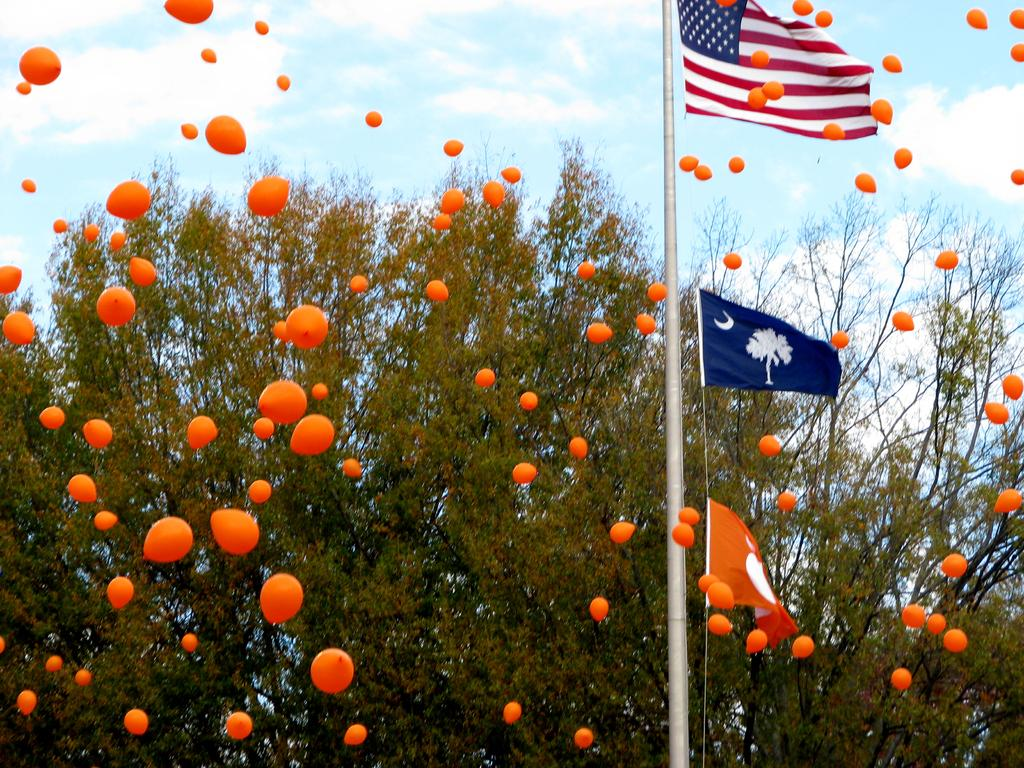What is the main structure in the image? There is a pole in the image. What is attached to the pole? There are flags in the image that are attached to the pole. What else can be seen in the image besides the pole and flags? There are balloons and a tree in the image. How would you describe the weather in the image? The sky is cloudy in the image, suggesting a partly cloudy or overcast day. What type of goat can be seen eating popcorn in the image? There is no goat or popcorn present in the image. 